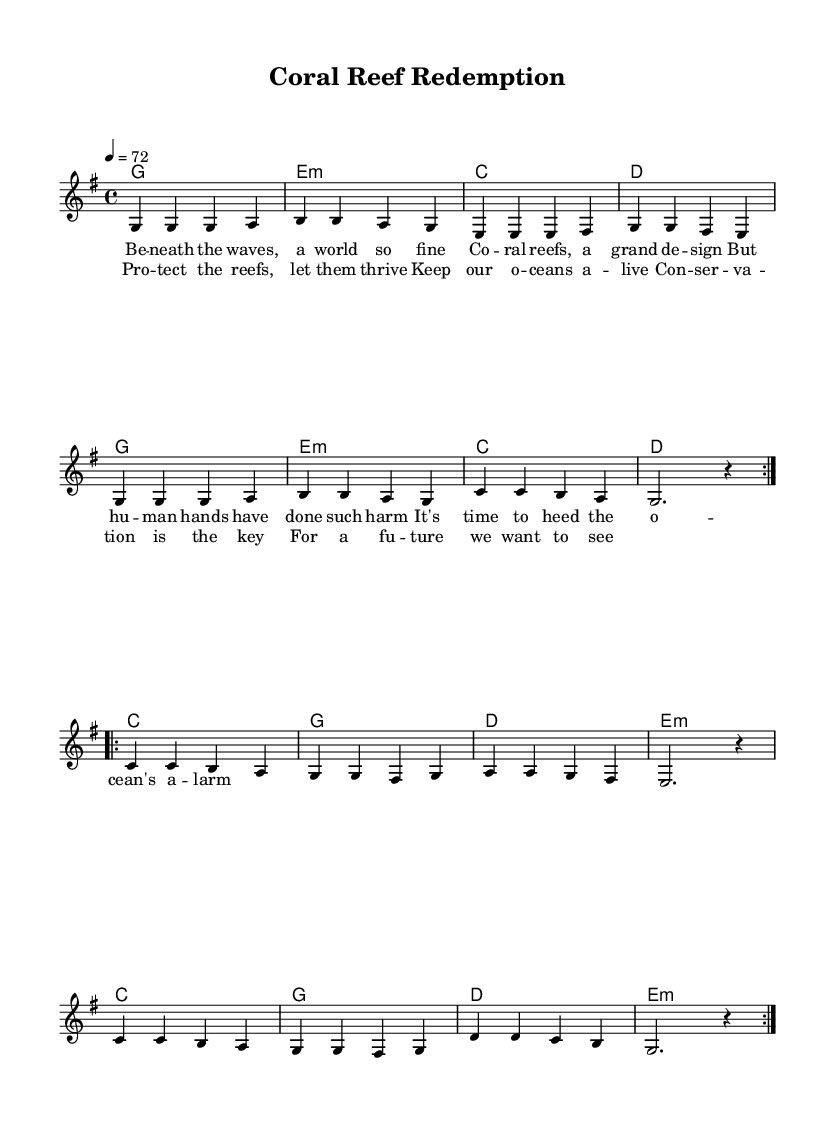What is the key signature of this music? The key signature shown in the music indicates G major, which has one sharp. The sharp is located on the F line of the staff.
Answer: G major What is the time signature of the piece? The time signature appears at the beginning of the piece and is written as 4/4. This means there are four beats in each measure and the quarter note gets the beat.
Answer: 4/4 What is the tempo marking of the music? The tempo marking provided is '4 = 72,' indicating that there are 72 quarter note beats in a minute. This is a moderate pace suitable for reggae music.
Answer: 72 How many repetitions are indicated for the first section of the melody? The first section of the melody is marked with a volta sign indicating it is to be played twice. This suggests that part of the melody has repeated phrases, which is common in reggae.
Answer: 2 What is the primary theme of the lyrics in this reggae song? The lyrics emphasize the importance of protecting ocean ecosystems, specifically coral reefs, which reflects common themes in reggae music related to social and environmental causes.
Answer: Ocean conservation Which chord is repeated most frequently in this piece? By analyzing the chord progression shown in the chord section, G major is noted to be used repetitively in multiple sections of the music, indicating its significance within the harmony.
Answer: G How do the lyrics reflect the music genre's characteristics? The lyrics focus on community call-to-action themes typical of reggae, emphasizing collective responsibility toward marine conservation, which resonates with the reggae genre's usual narrative style.
Answer: Collective responsibility 